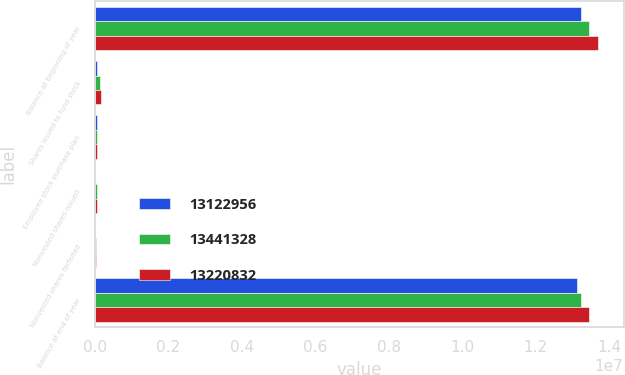<chart> <loc_0><loc_0><loc_500><loc_500><stacked_bar_chart><ecel><fcel>Balance at beginning of year<fcel>Shares issued to fund stock<fcel>Employee stock purchase plan<fcel>Nonvested shares issued<fcel>Nonvested shares forfeited<fcel>Balance at end of year<nl><fcel>1.3123e+07<fcel>1.32208e+07<fcel>54209<fcel>42391<fcel>5723<fcel>4447<fcel>1.3123e+07<nl><fcel>1.34413e+07<fcel>1.34413e+07<fcel>141728<fcel>44319<fcel>56136<fcel>21687<fcel>1.32208e+07<nl><fcel>1.32208e+07<fcel>1.37035e+07<fcel>158440<fcel>59390<fcel>57659<fcel>13364<fcel>1.34413e+07<nl></chart> 